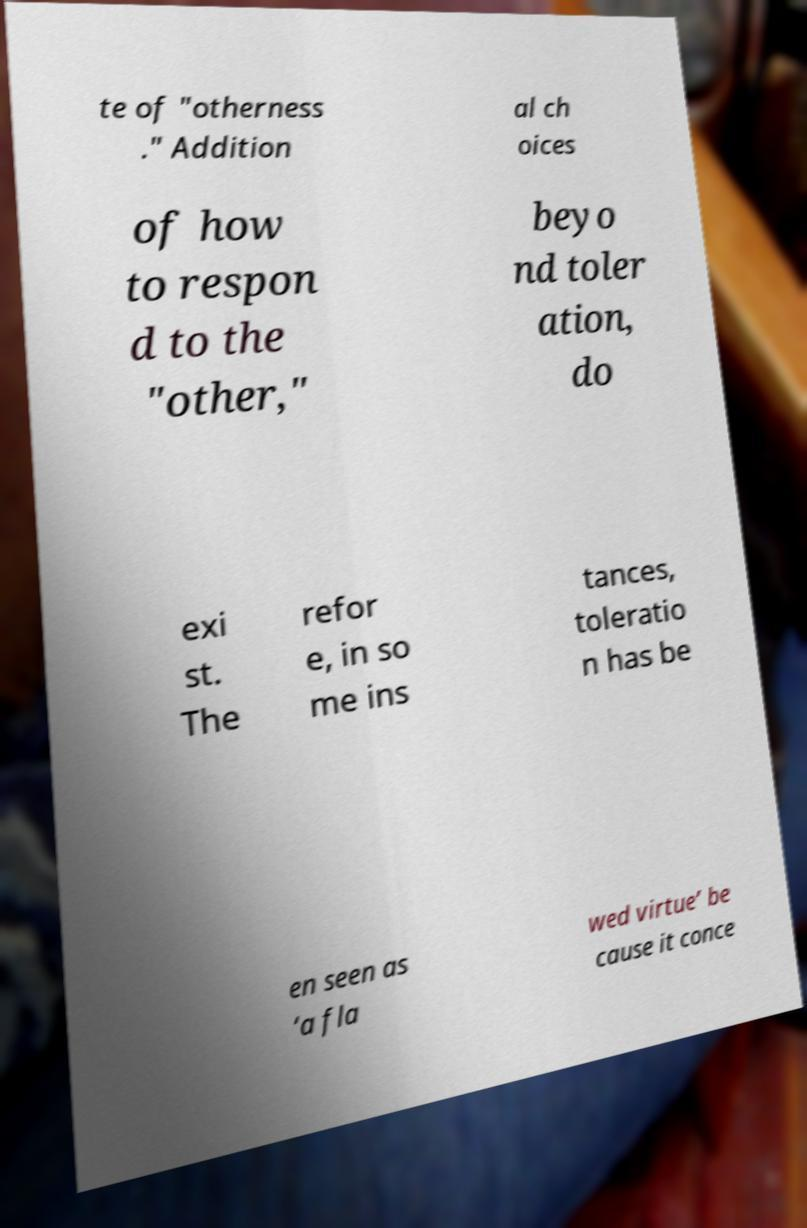Please identify and transcribe the text found in this image. te of "otherness ." Addition al ch oices of how to respon d to the "other," beyo nd toler ation, do exi st. The refor e, in so me ins tances, toleratio n has be en seen as ‘a fla wed virtue’ be cause it conce 